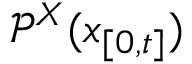<formula> <loc_0><loc_0><loc_500><loc_500>\mathcal { P } ^ { X } ( x _ { [ 0 , t ] } )</formula> 